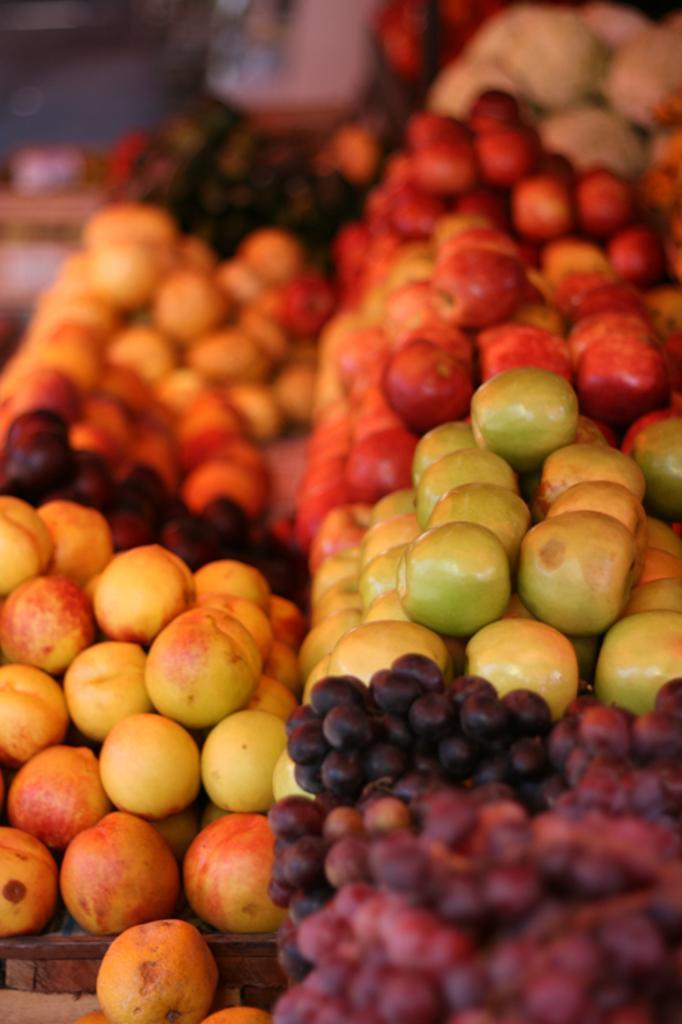Could you give a brief overview of what you see in this image? In this picture there are apples and grapes. The background is blurred. 